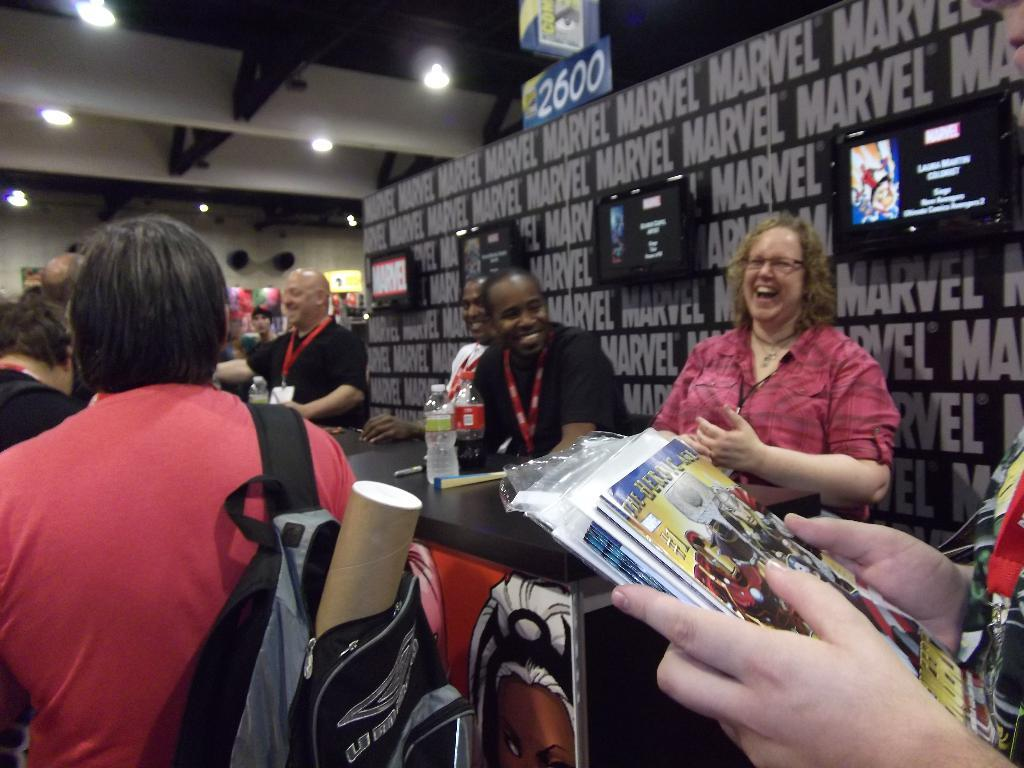<image>
Offer a succinct explanation of the picture presented. A group of people are sitting at a Marvel book at a convention. 